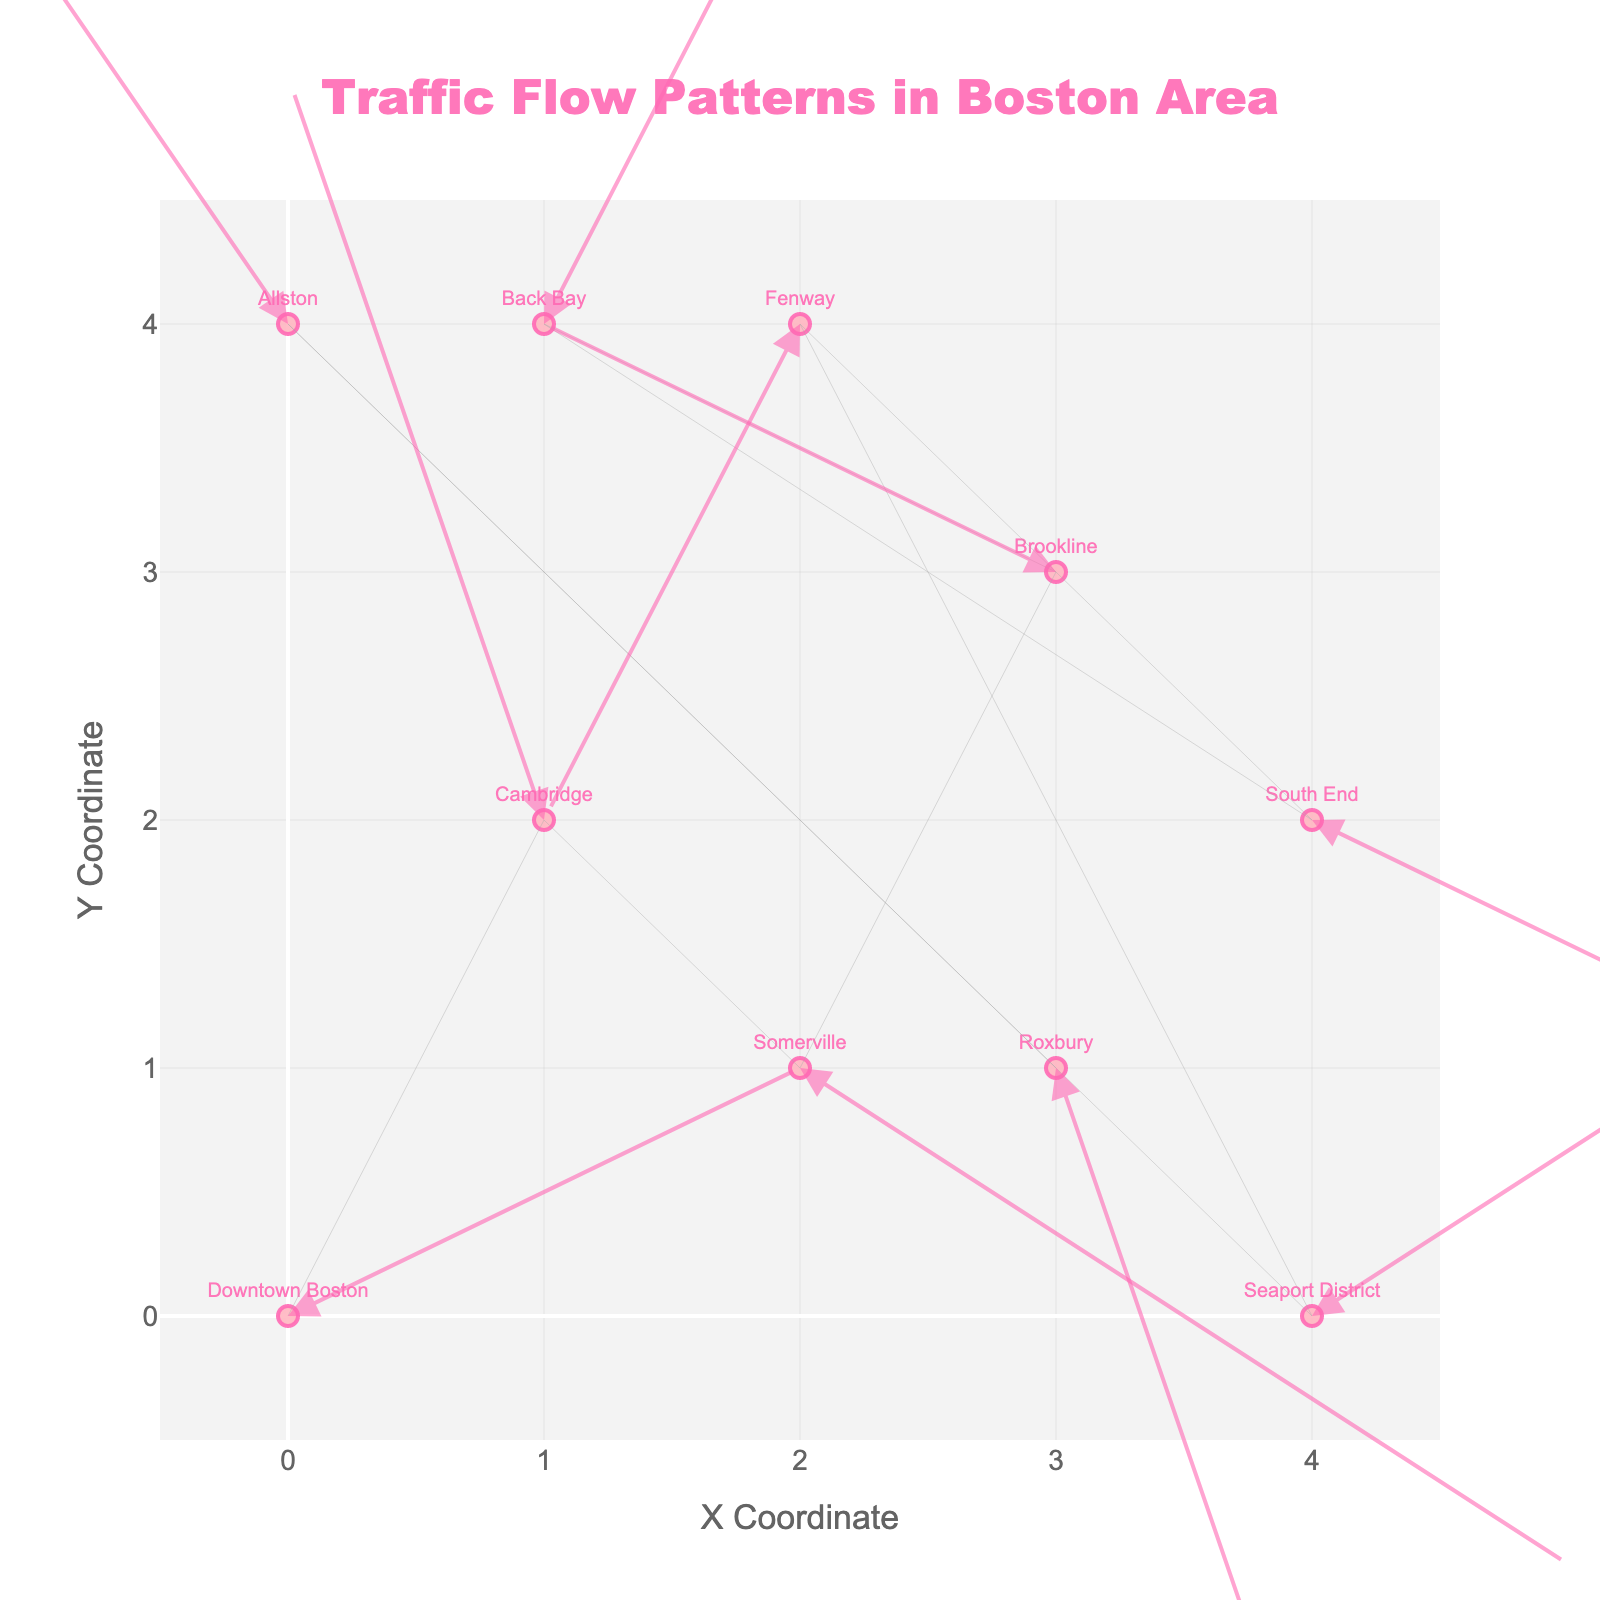What is the title of the figure? The title appears at the top of the plot, indicating the main subject of the visualization.
Answer: Traffic Flow Patterns in Boston Area How many locations are represented on the plot? Each marker in the plot represents a location, and we can count them by identifying the labeled points. There are ten markers with labels.
Answer: 10 Which location shows the highest movement in the positive x-direction? To determine the highest movement in the positive x-direction, we look for the longest arrow pointing rightward. In this plot, the Seaport District has an arrow (3,2) indicating the highest movement in the positive x-direction.
Answer: Seaport District Which location has the vector with the greatest negative y-component? By examining the vectors pointing downward, Somerville has a vector (3,-2), indicating the greatest negative y-component.
Answer: Somerville What is the direction of movement for the traffic flow in Cambridge? Read the u and v components for Cambridge, which are (-1, 3). A negative u indicates leftward movement, and a positive v indicates upward movement.
Answer: Leftward and upward Identify the locations that exhibit negative x-direction flow. Identify the arrows with negative u components: Cambridge (-1), Brookline (-2), Fenway (-1), Allston (-2), and Somerville (-3).
Answer: Cambridge, Brookline, Fenway, Allston, Somerville Which location experiences the lowest total movement magnitude? Calculate the magnitude of the vectors using sqrt(u^2 + v^2) for each location. Allston has the lowest magnitude with a vector (-2, 3), resulting in sqrt(2^2 + 3^2) = sqrt(13).
Answer: Allston What is the location at coordinates (1, 4)? The plot shows labels for each point. The label at position (1, 4) is associated with Back Bay.
Answer: Back Bay Compare the vectors for Roxbury and Downtown Boston. Which has a greater net movement? Calculate the magnitude for vectors of both locations. Roxbury has (1,-3) which equals sqrt(1^2 + 3^2) = sqrt(10), and Downtown Boston has (2, 1) equaling sqrt(4 + 1) = sqrt(5). Roxbury's magnitude is higher.
Answer: Roxbury 